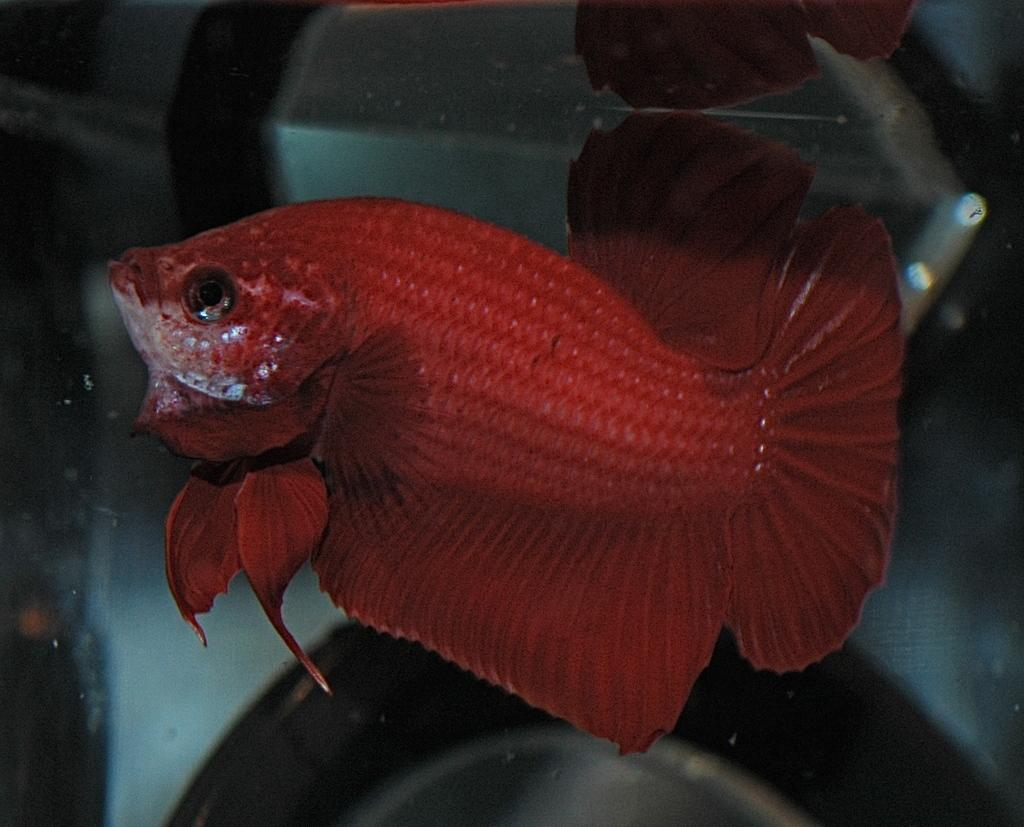What type of animal can be seen in the image? There is a fish in the water in the image. What type of yoke can be seen in the image? There is no yoke present in the image; it features a fish in the water. What type of pickle is floating next to the fish in the image? There is no pickle present in the image; it features a fish in the water. 